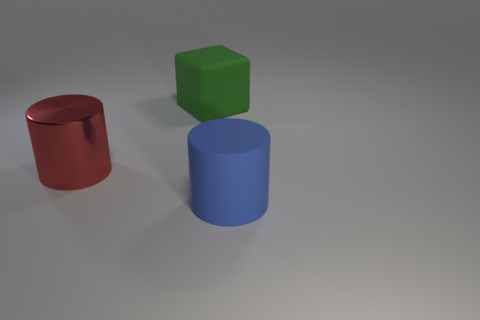Add 3 big blocks. How many objects exist? 6 Subtract all cubes. How many objects are left? 2 Subtract 0 purple balls. How many objects are left? 3 Subtract all rubber objects. Subtract all large green cubes. How many objects are left? 0 Add 2 large blue objects. How many large blue objects are left? 3 Add 2 yellow metal spheres. How many yellow metal spheres exist? 2 